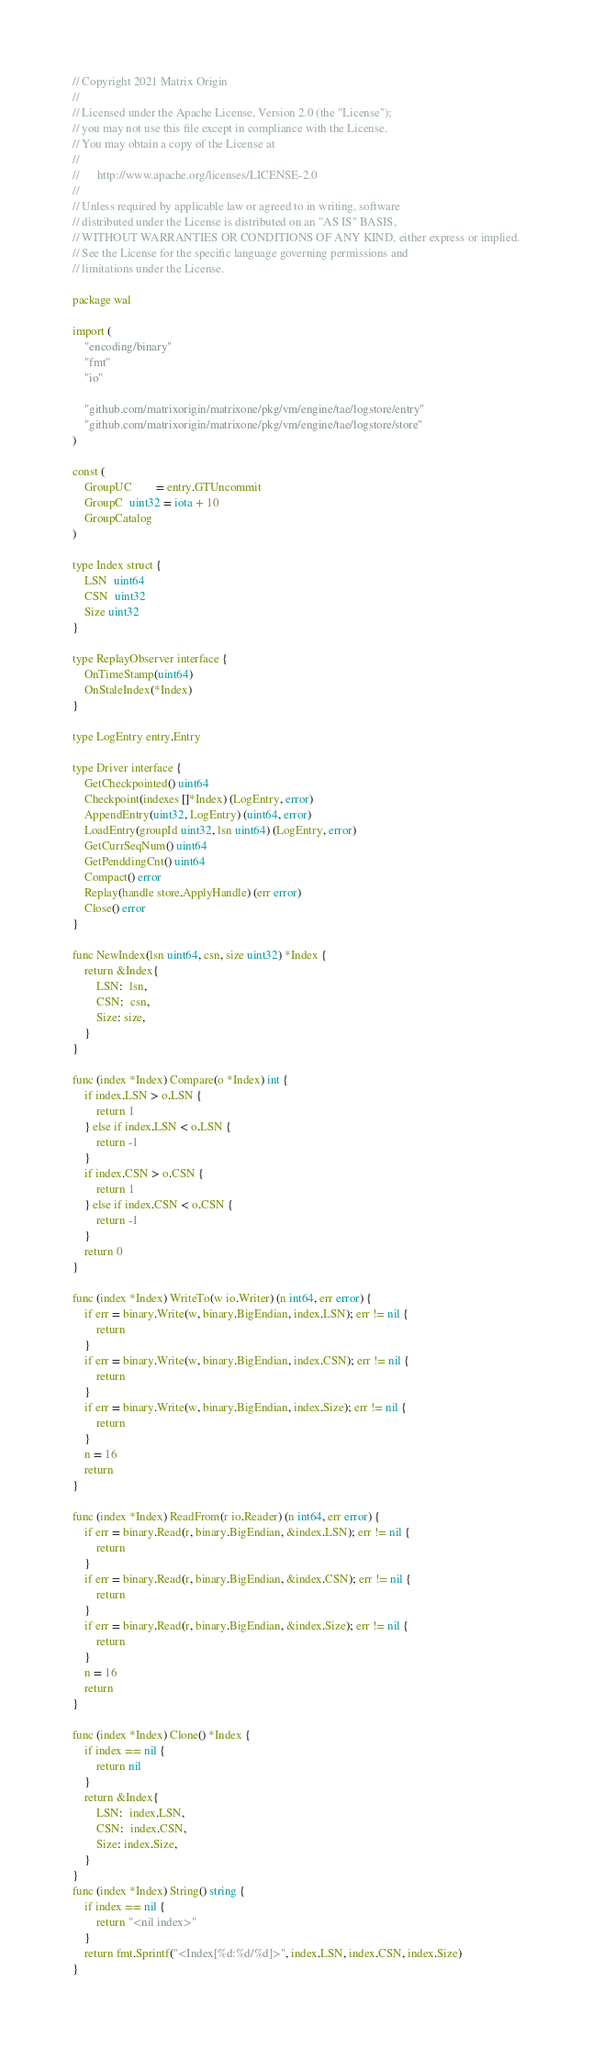<code> <loc_0><loc_0><loc_500><loc_500><_Go_>// Copyright 2021 Matrix Origin
//
// Licensed under the Apache License, Version 2.0 (the "License");
// you may not use this file except in compliance with the License.
// You may obtain a copy of the License at
//
//      http://www.apache.org/licenses/LICENSE-2.0
//
// Unless required by applicable law or agreed to in writing, software
// distributed under the License is distributed on an "AS IS" BASIS,
// WITHOUT WARRANTIES OR CONDITIONS OF ANY KIND, either express or implied.
// See the License for the specific language governing permissions and
// limitations under the License.

package wal

import (
	"encoding/binary"
	"fmt"
	"io"

	"github.com/matrixorigin/matrixone/pkg/vm/engine/tae/logstore/entry"
	"github.com/matrixorigin/matrixone/pkg/vm/engine/tae/logstore/store"
)

const (
	GroupUC        = entry.GTUncommit
	GroupC  uint32 = iota + 10
	GroupCatalog
)

type Index struct {
	LSN  uint64
	CSN  uint32
	Size uint32
}

type ReplayObserver interface {
	OnTimeStamp(uint64)
	OnStaleIndex(*Index)
}

type LogEntry entry.Entry

type Driver interface {
	GetCheckpointed() uint64
	Checkpoint(indexes []*Index) (LogEntry, error)
	AppendEntry(uint32, LogEntry) (uint64, error)
	LoadEntry(groupId uint32, lsn uint64) (LogEntry, error)
	GetCurrSeqNum() uint64
	GetPenddingCnt() uint64
	Compact() error
	Replay(handle store.ApplyHandle) (err error)
	Close() error
}

func NewIndex(lsn uint64, csn, size uint32) *Index {
	return &Index{
		LSN:  lsn,
		CSN:  csn,
		Size: size,
	}
}

func (index *Index) Compare(o *Index) int {
	if index.LSN > o.LSN {
		return 1
	} else if index.LSN < o.LSN {
		return -1
	}
	if index.CSN > o.CSN {
		return 1
	} else if index.CSN < o.CSN {
		return -1
	}
	return 0
}

func (index *Index) WriteTo(w io.Writer) (n int64, err error) {
	if err = binary.Write(w, binary.BigEndian, index.LSN); err != nil {
		return
	}
	if err = binary.Write(w, binary.BigEndian, index.CSN); err != nil {
		return
	}
	if err = binary.Write(w, binary.BigEndian, index.Size); err != nil {
		return
	}
	n = 16
	return
}

func (index *Index) ReadFrom(r io.Reader) (n int64, err error) {
	if err = binary.Read(r, binary.BigEndian, &index.LSN); err != nil {
		return
	}
	if err = binary.Read(r, binary.BigEndian, &index.CSN); err != nil {
		return
	}
	if err = binary.Read(r, binary.BigEndian, &index.Size); err != nil {
		return
	}
	n = 16
	return
}

func (index *Index) Clone() *Index {
	if index == nil {
		return nil
	}
	return &Index{
		LSN:  index.LSN,
		CSN:  index.CSN,
		Size: index.Size,
	}
}
func (index *Index) String() string {
	if index == nil {
		return "<nil index>"
	}
	return fmt.Sprintf("<Index[%d:%d/%d]>", index.LSN, index.CSN, index.Size)
}
</code> 